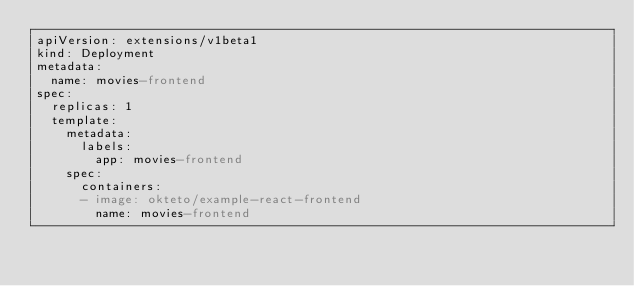Convert code to text. <code><loc_0><loc_0><loc_500><loc_500><_YAML_>apiVersion: extensions/v1beta1
kind: Deployment
metadata:
  name: movies-frontend
spec:
  replicas: 1
  template:
    metadata:
      labels:
        app: movies-frontend
    spec:
      containers:
      - image: okteto/example-react-frontend
        name: movies-frontend</code> 